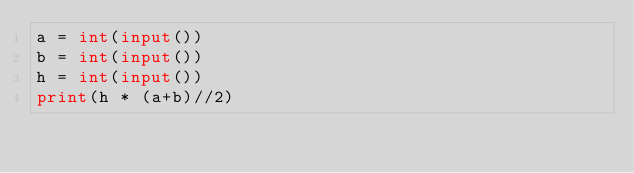Convert code to text. <code><loc_0><loc_0><loc_500><loc_500><_Python_>a = int(input())
b = int(input())
h = int(input())
print(h * (a+b)//2)</code> 